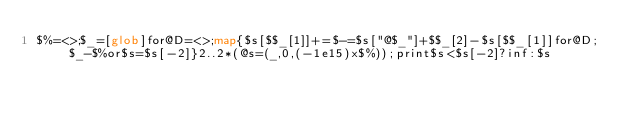<code> <loc_0><loc_0><loc_500><loc_500><_Perl_>$%=<>;$_=[glob]for@D=<>;map{$s[$$_[1]]+=$-=$s["@$_"]+$$_[2]-$s[$$_[1]]for@D;$_-$%or$s=$s[-2]}2..2*(@s=(_,0,(-1e15)x$%));print$s<$s[-2]?inf:$s</code> 